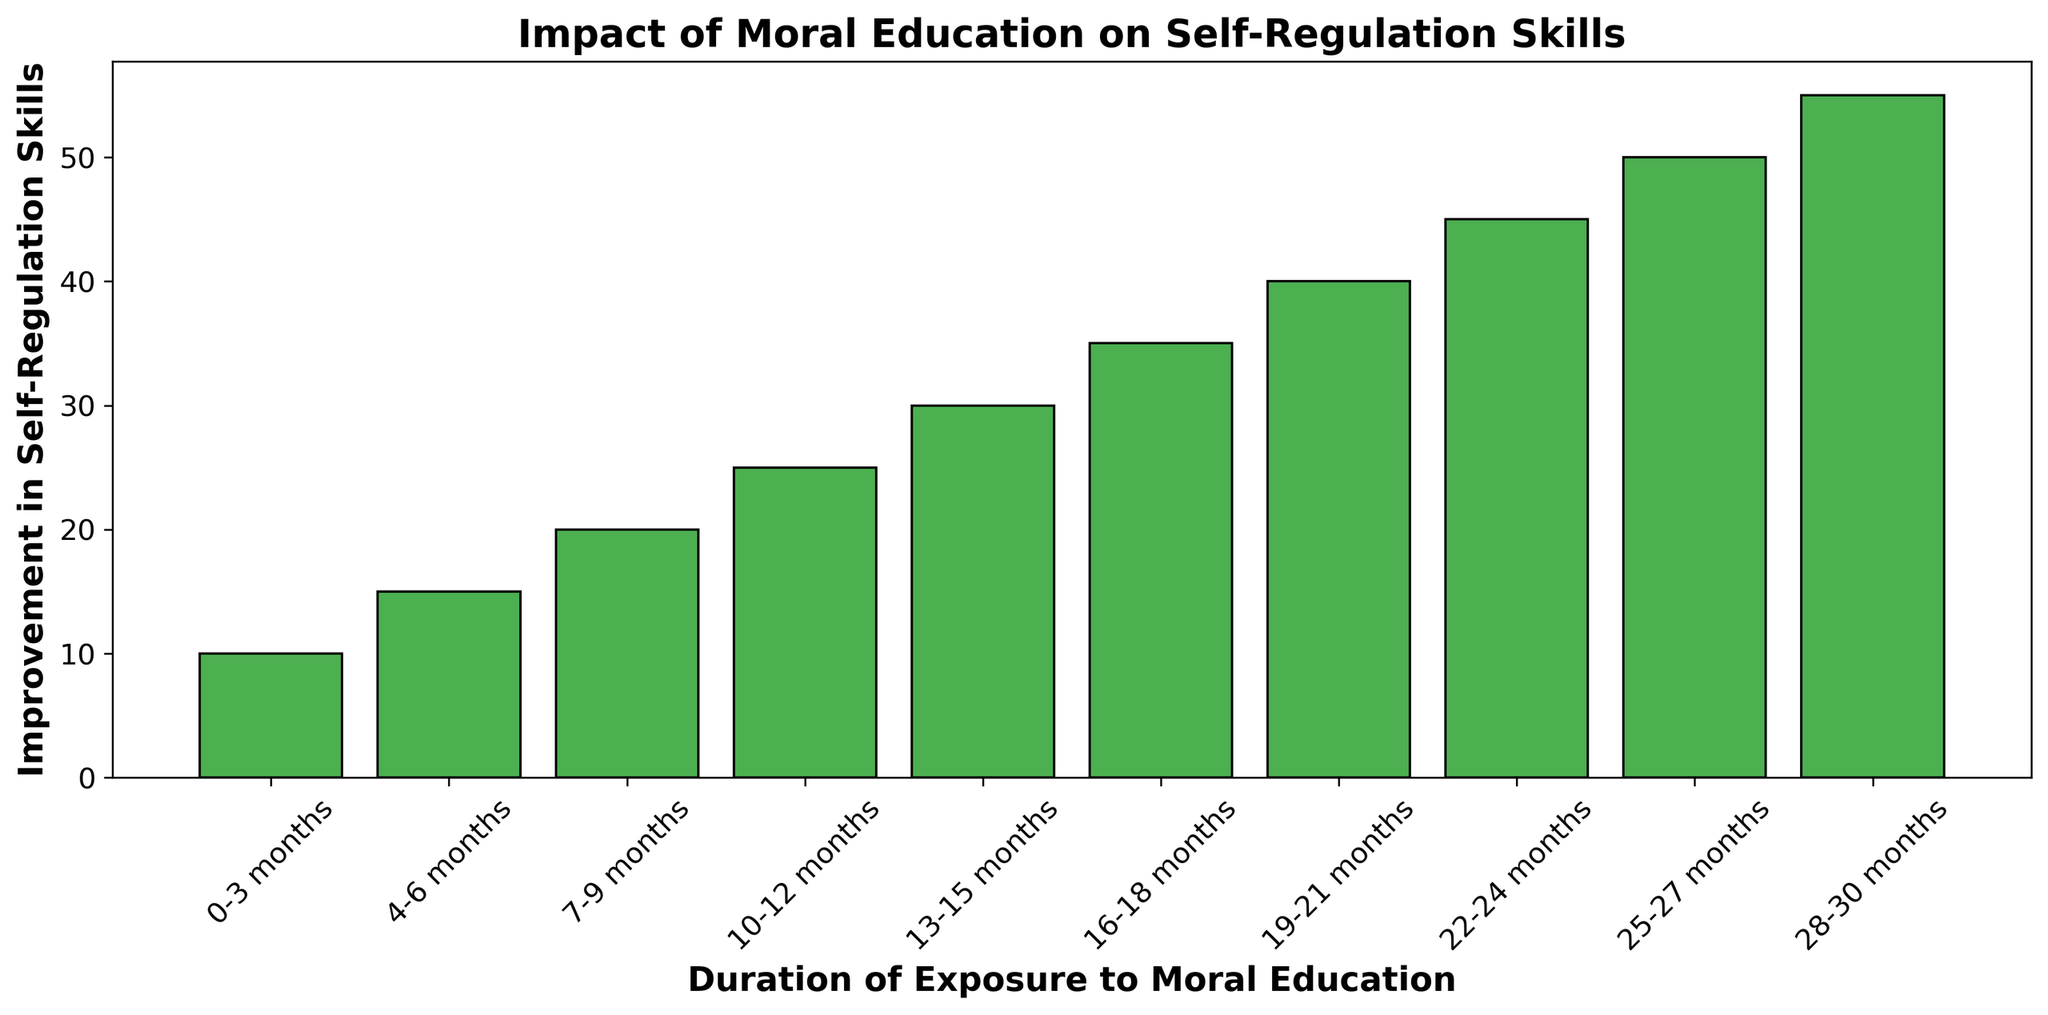What is the duration of exposure that leads to the highest improvement in self-regulation skills? To find the duration with the highest improvement, look at the bar with the greatest height. The bar for 28-30 months is the tallest, indicating the highest improvement in self-regulation skills.
Answer: 28-30 months What is the total improvement in self-regulation skills for exposures between 19-24 months? Sum the improvement values for the durations 19-21 months and 22-24 months. They are 40 and 45 respectively. The total is 40 + 45 = 85.
Answer: 85 Compare the improvement in self-regulation skills between 0-3 months and 16-18 months. Examine the bars for 0-3 months and 16-18 months. The height of the bar for 0-3 months is 10, while 16-18 months is 35. Since 35 is greater than 10, 16-18 months shows greater improvement.
Answer: 16-18 months is greater Is the improvement in self-regulation skills for 10-12 months less than or equal to that for 13-15 months? Compare the heights of the bars for 10-12 months and 13-15 months. The bar for 10-12 months is 25 and for 13-15 months is 30. Since 25 is less than 30, the improvement for 10-12 months is less.
Answer: Yes What is the average improvement in self-regulation skills for the durations from 7-12 months? Average the improvement values for 7-9 months, 10-12 months. Add 20 (7-9 months) and 25 (10-12 months), divide by 2. (20+25)/2 = 22.5.
Answer: 22.5 How does the improvement in self-regulation skills for 4-6 months compare to that of 25-27 months? Compare the heights of the bars for 4-6 months and 25-27 months. The height for 4-6 months is 15, while for 25-27 months it is 50. Therefore, 25-27 months shows greater improvement.
Answer: 25-27 months is greater Which duration(s) shows a greater improvement compared to the 13-15 months exposure duration? Identify bars taller than the bar for 13-15 months which is at 30. Durations 16-18 months (35), 19-21 months (40), 22-24 months (45), 25-27 months (50), and 28-30 months (55) have greater improvements.
Answer: 16-18, 19-21, 22-24, 25-27, 28-30 months What is the difference in improvement in self-regulation skills between 22-24 months and 7-9 months? Subtract the improvement at 7-9 months (20) from the improvement at 22-24 months (45). The difference is 45 - 20 = 25.
Answer: 25 What is the median improvement in self-regulation skills for the durations listed? Arrange the improvements in ascending order: 10, 15, 20, 25, 30, 35, 40, 45, 50, 55. The median is the average of the 5th and 6th values: (30 + 35)/2 = 32.5.
Answer: 32.5 Is the improvement consistent across all durations, or does it show a trend? Observe the general increase in the heights of the bars as the durations increase, indicating a trend of increasing improvement with longer exposure durations.
Answer: Shows a trend of increasing improvement 